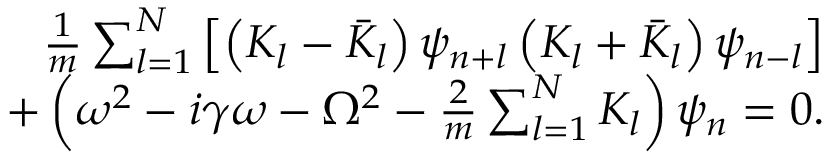Convert formula to latex. <formula><loc_0><loc_0><loc_500><loc_500>\begin{array} { r l r } & { \frac { 1 } { m } \sum _ { l = 1 } ^ { N } \left [ \left ( K _ { l } - \bar { K } _ { l } \right ) \psi _ { n + l } \left ( K _ { l } + \bar { K } _ { l } \right ) \psi _ { n - l } \right ] } \\ & { + \left ( \omega ^ { 2 } - i \gamma \omega - \Omega ^ { 2 } - \frac { 2 } { m } \sum _ { l = 1 } ^ { N } K _ { l } \right ) \psi _ { n } = 0 . } \end{array}</formula> 